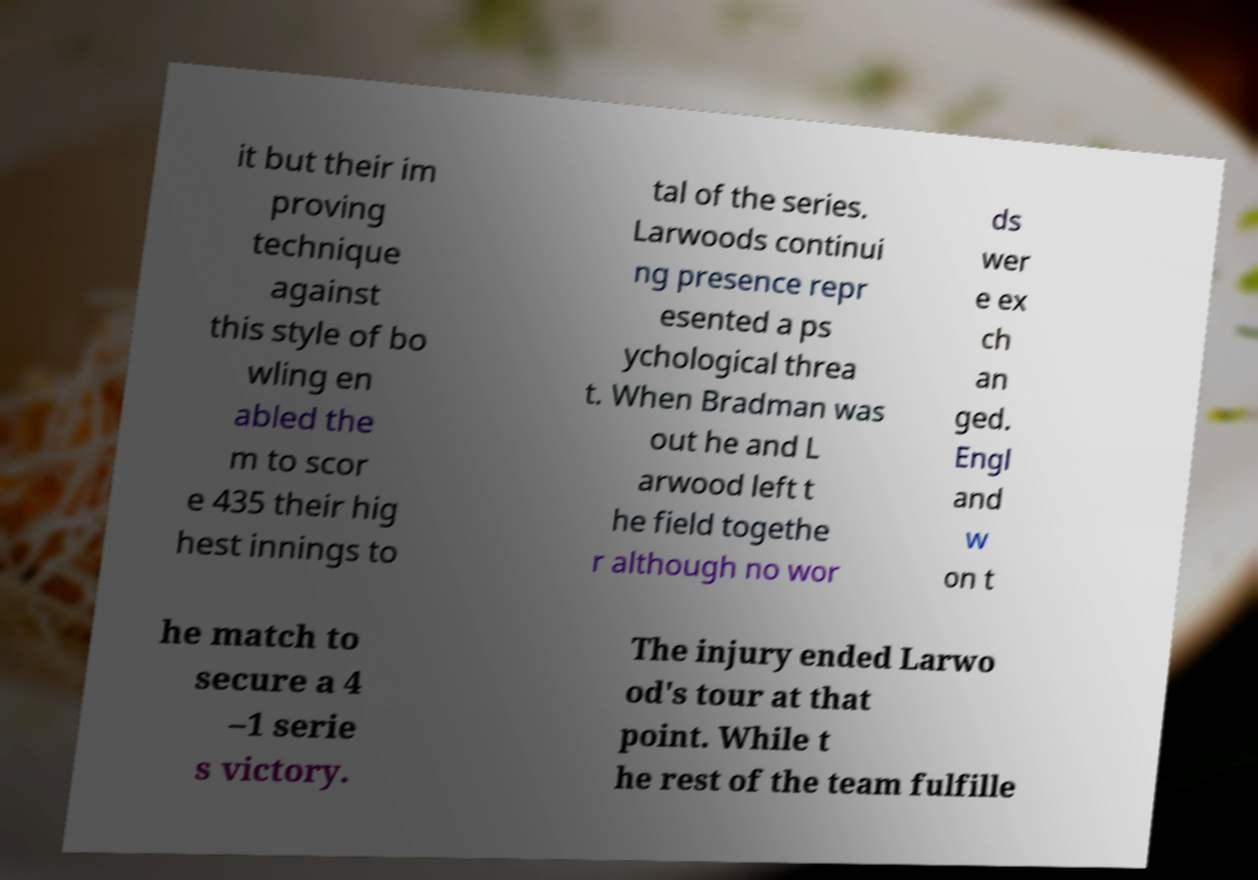There's text embedded in this image that I need extracted. Can you transcribe it verbatim? it but their im proving technique against this style of bo wling en abled the m to scor e 435 their hig hest innings to tal of the series. Larwoods continui ng presence repr esented a ps ychological threa t. When Bradman was out he and L arwood left t he field togethe r although no wor ds wer e ex ch an ged. Engl and w on t he match to secure a 4 –1 serie s victory. The injury ended Larwo od's tour at that point. While t he rest of the team fulfille 